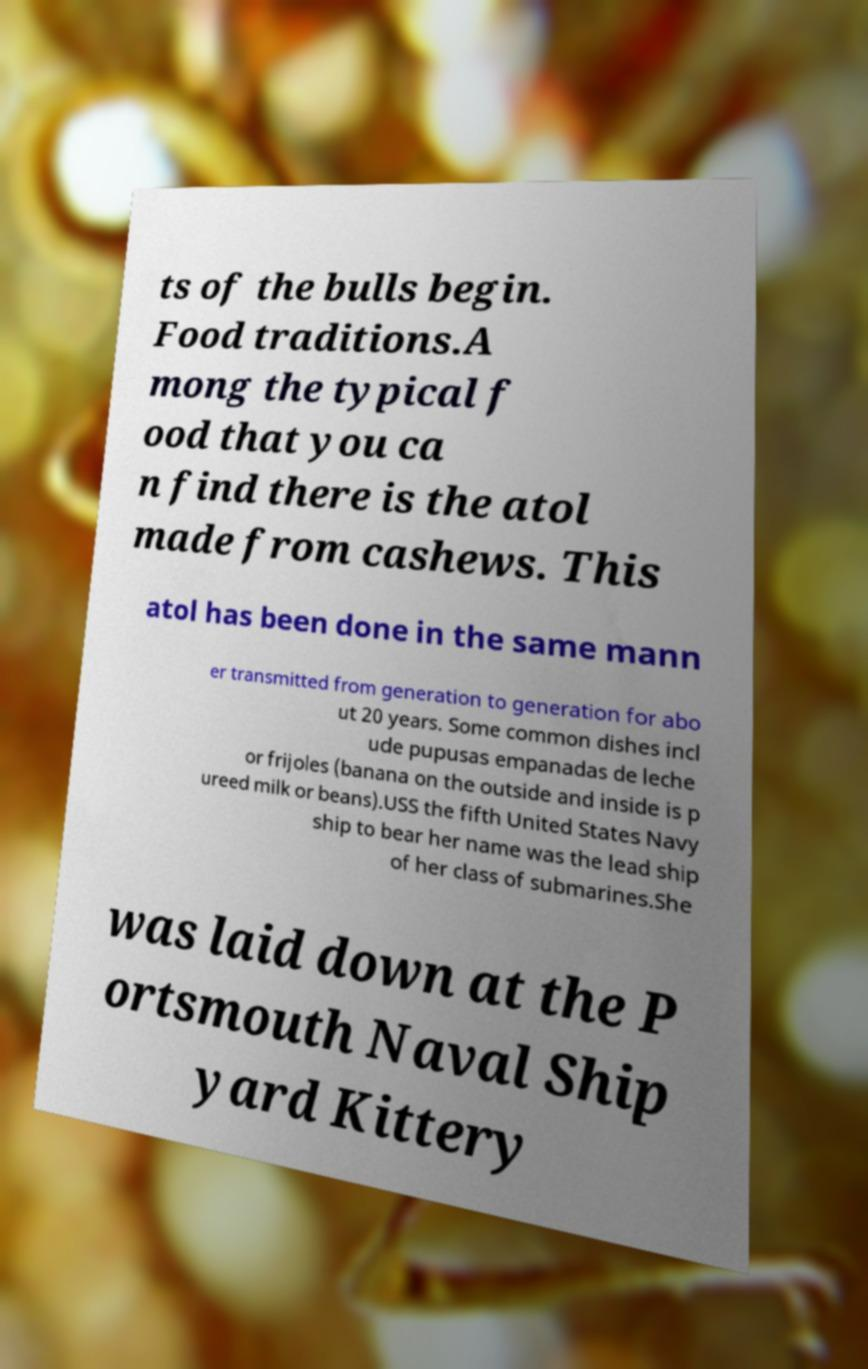Please read and relay the text visible in this image. What does it say? ts of the bulls begin. Food traditions.A mong the typical f ood that you ca n find there is the atol made from cashews. This atol has been done in the same mann er transmitted from generation to generation for abo ut 20 years. Some common dishes incl ude pupusas empanadas de leche or frijoles (banana on the outside and inside is p ureed milk or beans).USS the fifth United States Navy ship to bear her name was the lead ship of her class of submarines.She was laid down at the P ortsmouth Naval Ship yard Kittery 